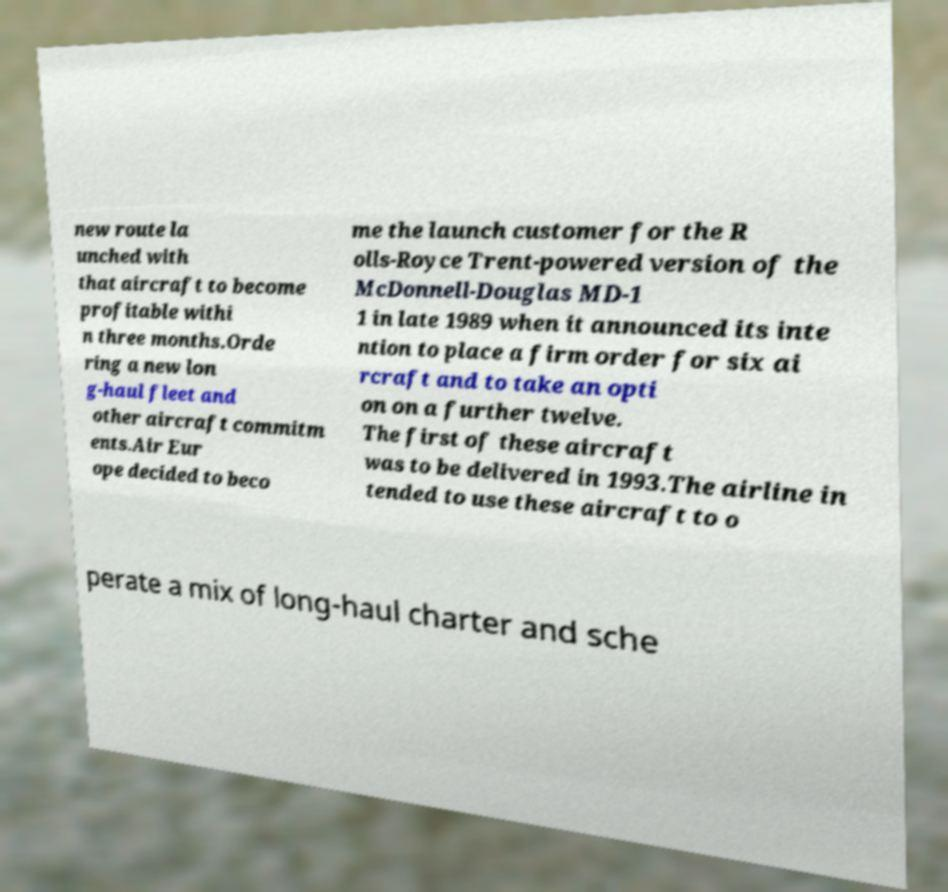Can you accurately transcribe the text from the provided image for me? new route la unched with that aircraft to become profitable withi n three months.Orde ring a new lon g-haul fleet and other aircraft commitm ents.Air Eur ope decided to beco me the launch customer for the R olls-Royce Trent-powered version of the McDonnell-Douglas MD-1 1 in late 1989 when it announced its inte ntion to place a firm order for six ai rcraft and to take an opti on on a further twelve. The first of these aircraft was to be delivered in 1993.The airline in tended to use these aircraft to o perate a mix of long-haul charter and sche 